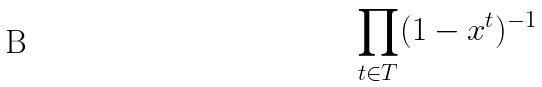Convert formula to latex. <formula><loc_0><loc_0><loc_500><loc_500>\prod _ { t \in T } ( 1 - x ^ { t } ) ^ { - 1 }</formula> 